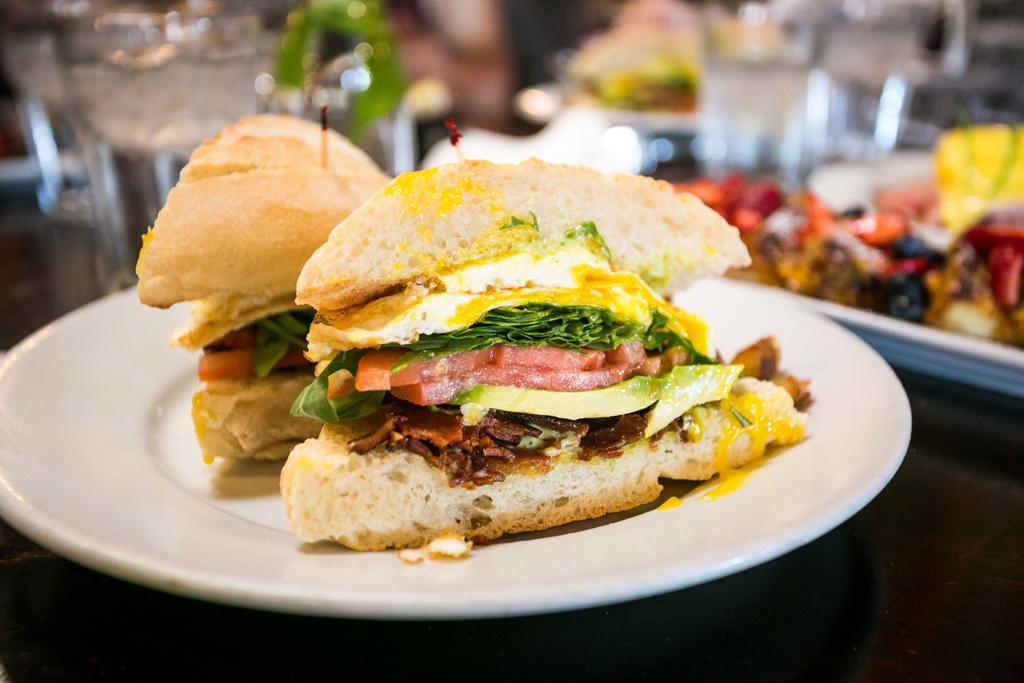Please provide a concise description of this image. In this Image I can see a food. Food is in brown,white,yellow,green and red color. Background is blurred. 